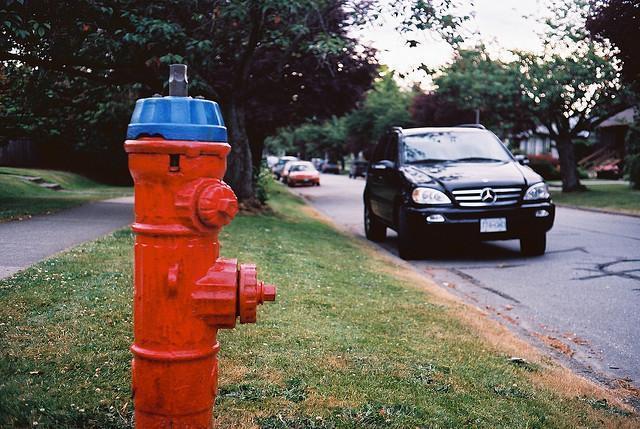Why is the black vehicle stopped near the curb?
From the following four choices, select the correct answer to address the question.
Options: To load, to race, to deliver, to park. To park. 